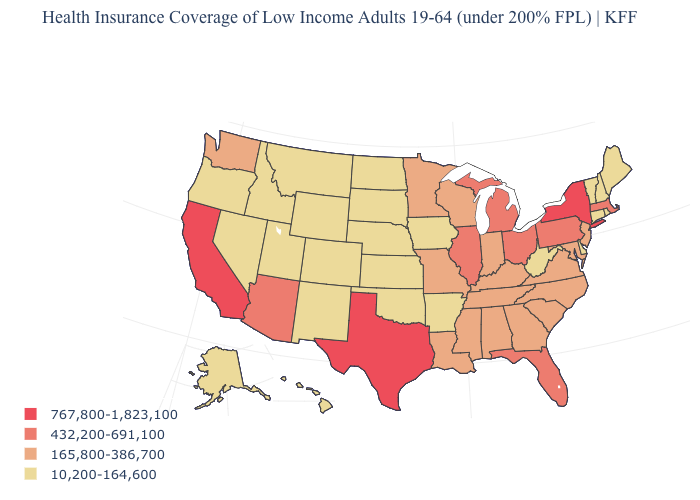What is the lowest value in the USA?
Concise answer only. 10,200-164,600. Is the legend a continuous bar?
Keep it brief. No. Among the states that border Kansas , which have the highest value?
Keep it brief. Missouri. How many symbols are there in the legend?
Give a very brief answer. 4. What is the highest value in the USA?
Be succinct. 767,800-1,823,100. Among the states that border Arizona , does California have the lowest value?
Give a very brief answer. No. Name the states that have a value in the range 10,200-164,600?
Give a very brief answer. Alaska, Arkansas, Colorado, Connecticut, Delaware, Hawaii, Idaho, Iowa, Kansas, Maine, Montana, Nebraska, Nevada, New Hampshire, New Mexico, North Dakota, Oklahoma, Oregon, Rhode Island, South Dakota, Utah, Vermont, West Virginia, Wyoming. Name the states that have a value in the range 165,800-386,700?
Quick response, please. Alabama, Georgia, Indiana, Kentucky, Louisiana, Maryland, Minnesota, Mississippi, Missouri, New Jersey, North Carolina, South Carolina, Tennessee, Virginia, Washington, Wisconsin. What is the lowest value in the South?
Quick response, please. 10,200-164,600. Name the states that have a value in the range 10,200-164,600?
Write a very short answer. Alaska, Arkansas, Colorado, Connecticut, Delaware, Hawaii, Idaho, Iowa, Kansas, Maine, Montana, Nebraska, Nevada, New Hampshire, New Mexico, North Dakota, Oklahoma, Oregon, Rhode Island, South Dakota, Utah, Vermont, West Virginia, Wyoming. Does New Mexico have a lower value than Texas?
Concise answer only. Yes. What is the value of Ohio?
Short answer required. 432,200-691,100. Name the states that have a value in the range 432,200-691,100?
Quick response, please. Arizona, Florida, Illinois, Massachusetts, Michigan, Ohio, Pennsylvania. Name the states that have a value in the range 165,800-386,700?
Give a very brief answer. Alabama, Georgia, Indiana, Kentucky, Louisiana, Maryland, Minnesota, Mississippi, Missouri, New Jersey, North Carolina, South Carolina, Tennessee, Virginia, Washington, Wisconsin. 